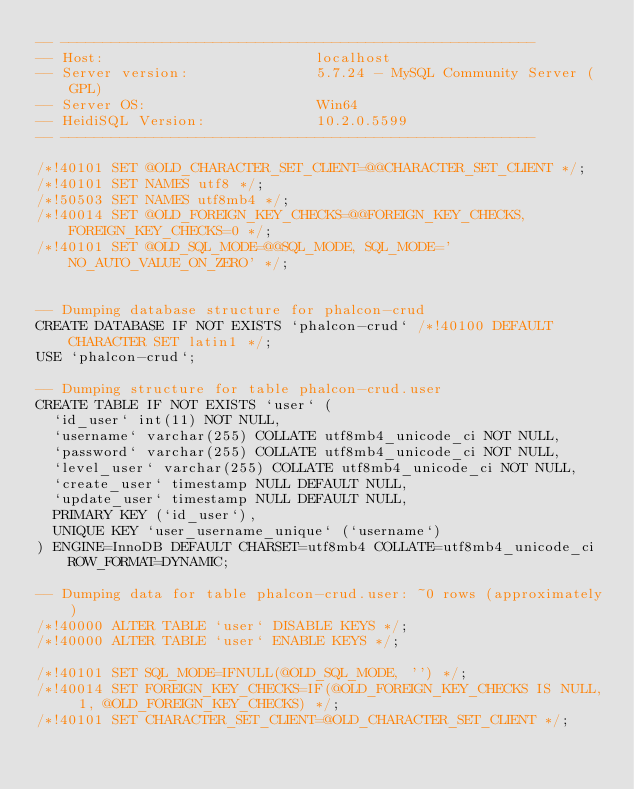<code> <loc_0><loc_0><loc_500><loc_500><_SQL_>-- --------------------------------------------------------
-- Host:                         localhost
-- Server version:               5.7.24 - MySQL Community Server (GPL)
-- Server OS:                    Win64
-- HeidiSQL Version:             10.2.0.5599
-- --------------------------------------------------------

/*!40101 SET @OLD_CHARACTER_SET_CLIENT=@@CHARACTER_SET_CLIENT */;
/*!40101 SET NAMES utf8 */;
/*!50503 SET NAMES utf8mb4 */;
/*!40014 SET @OLD_FOREIGN_KEY_CHECKS=@@FOREIGN_KEY_CHECKS, FOREIGN_KEY_CHECKS=0 */;
/*!40101 SET @OLD_SQL_MODE=@@SQL_MODE, SQL_MODE='NO_AUTO_VALUE_ON_ZERO' */;


-- Dumping database structure for phalcon-crud
CREATE DATABASE IF NOT EXISTS `phalcon-crud` /*!40100 DEFAULT CHARACTER SET latin1 */;
USE `phalcon-crud`;

-- Dumping structure for table phalcon-crud.user
CREATE TABLE IF NOT EXISTS `user` (
  `id_user` int(11) NOT NULL,
  `username` varchar(255) COLLATE utf8mb4_unicode_ci NOT NULL,
  `password` varchar(255) COLLATE utf8mb4_unicode_ci NOT NULL,
  `level_user` varchar(255) COLLATE utf8mb4_unicode_ci NOT NULL,
  `create_user` timestamp NULL DEFAULT NULL,
  `update_user` timestamp NULL DEFAULT NULL,
  PRIMARY KEY (`id_user`),
  UNIQUE KEY `user_username_unique` (`username`)
) ENGINE=InnoDB DEFAULT CHARSET=utf8mb4 COLLATE=utf8mb4_unicode_ci ROW_FORMAT=DYNAMIC;

-- Dumping data for table phalcon-crud.user: ~0 rows (approximately)
/*!40000 ALTER TABLE `user` DISABLE KEYS */;
/*!40000 ALTER TABLE `user` ENABLE KEYS */;

/*!40101 SET SQL_MODE=IFNULL(@OLD_SQL_MODE, '') */;
/*!40014 SET FOREIGN_KEY_CHECKS=IF(@OLD_FOREIGN_KEY_CHECKS IS NULL, 1, @OLD_FOREIGN_KEY_CHECKS) */;
/*!40101 SET CHARACTER_SET_CLIENT=@OLD_CHARACTER_SET_CLIENT */;
</code> 